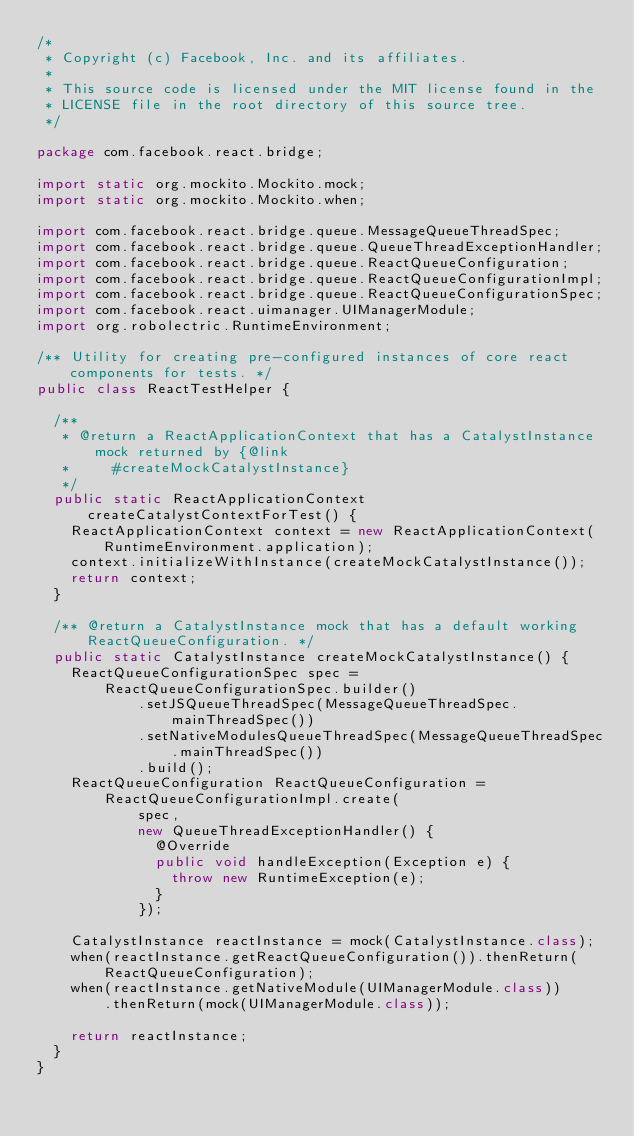Convert code to text. <code><loc_0><loc_0><loc_500><loc_500><_Java_>/*
 * Copyright (c) Facebook, Inc. and its affiliates.
 *
 * This source code is licensed under the MIT license found in the
 * LICENSE file in the root directory of this source tree.
 */

package com.facebook.react.bridge;

import static org.mockito.Mockito.mock;
import static org.mockito.Mockito.when;

import com.facebook.react.bridge.queue.MessageQueueThreadSpec;
import com.facebook.react.bridge.queue.QueueThreadExceptionHandler;
import com.facebook.react.bridge.queue.ReactQueueConfiguration;
import com.facebook.react.bridge.queue.ReactQueueConfigurationImpl;
import com.facebook.react.bridge.queue.ReactQueueConfigurationSpec;
import com.facebook.react.uimanager.UIManagerModule;
import org.robolectric.RuntimeEnvironment;

/** Utility for creating pre-configured instances of core react components for tests. */
public class ReactTestHelper {

  /**
   * @return a ReactApplicationContext that has a CatalystInstance mock returned by {@link
   *     #createMockCatalystInstance}
   */
  public static ReactApplicationContext createCatalystContextForTest() {
    ReactApplicationContext context = new ReactApplicationContext(RuntimeEnvironment.application);
    context.initializeWithInstance(createMockCatalystInstance());
    return context;
  }

  /** @return a CatalystInstance mock that has a default working ReactQueueConfiguration. */
  public static CatalystInstance createMockCatalystInstance() {
    ReactQueueConfigurationSpec spec =
        ReactQueueConfigurationSpec.builder()
            .setJSQueueThreadSpec(MessageQueueThreadSpec.mainThreadSpec())
            .setNativeModulesQueueThreadSpec(MessageQueueThreadSpec.mainThreadSpec())
            .build();
    ReactQueueConfiguration ReactQueueConfiguration =
        ReactQueueConfigurationImpl.create(
            spec,
            new QueueThreadExceptionHandler() {
              @Override
              public void handleException(Exception e) {
                throw new RuntimeException(e);
              }
            });

    CatalystInstance reactInstance = mock(CatalystInstance.class);
    when(reactInstance.getReactQueueConfiguration()).thenReturn(ReactQueueConfiguration);
    when(reactInstance.getNativeModule(UIManagerModule.class))
        .thenReturn(mock(UIManagerModule.class));

    return reactInstance;
  }
}
</code> 